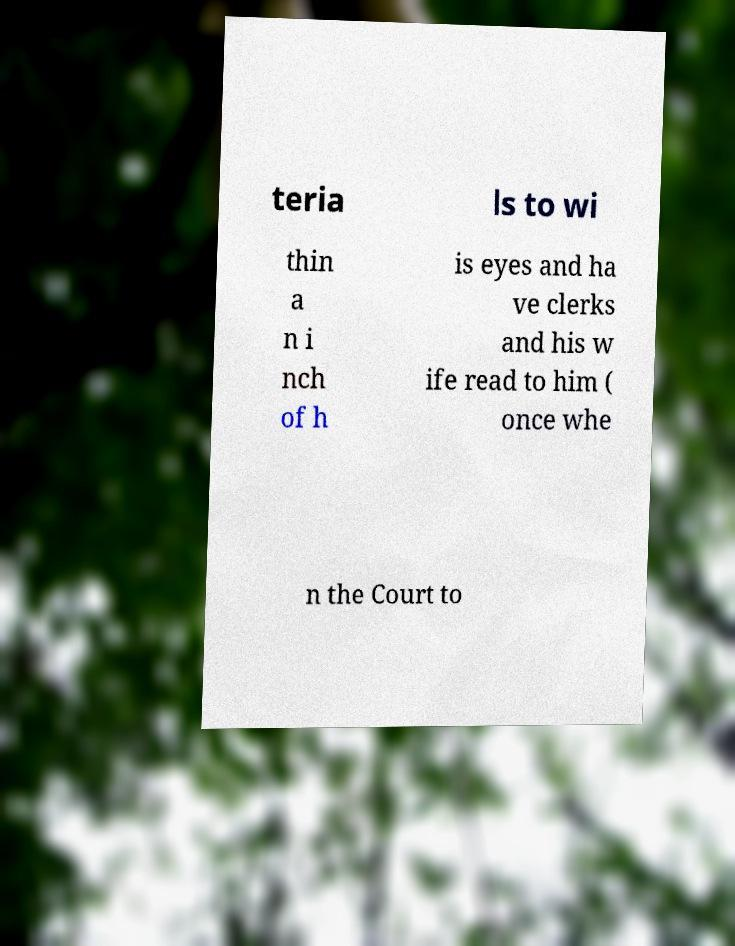I need the written content from this picture converted into text. Can you do that? teria ls to wi thin a n i nch of h is eyes and ha ve clerks and his w ife read to him ( once whe n the Court to 